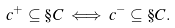<formula> <loc_0><loc_0><loc_500><loc_500>c ^ { + } \subseteq \S C \iff c ^ { - } \subseteq \S C .</formula> 